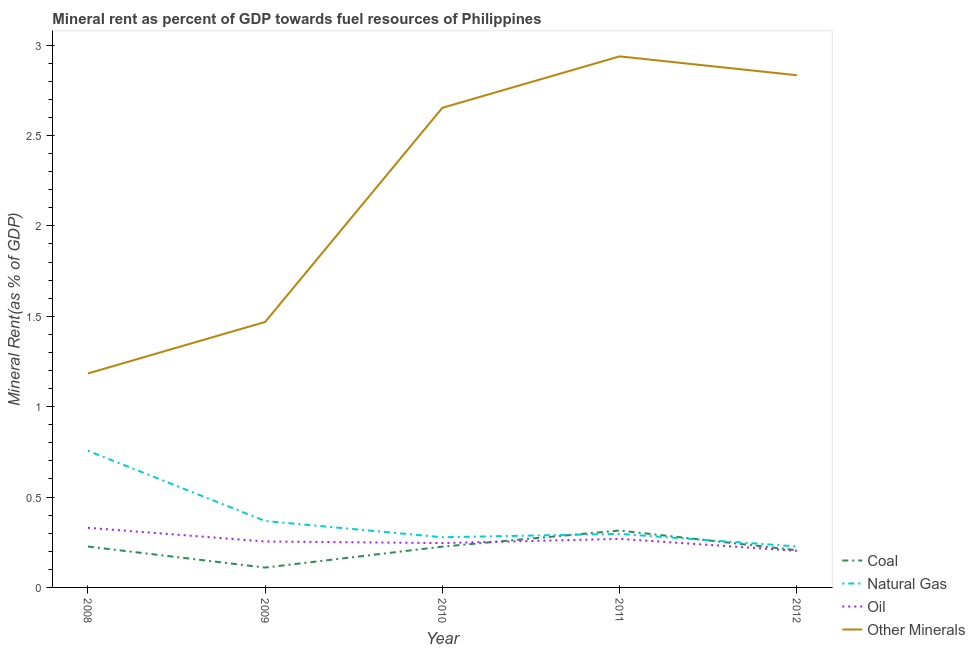What is the natural gas rent in 2011?
Your response must be concise. 0.3. Across all years, what is the maximum natural gas rent?
Your answer should be very brief. 0.76. Across all years, what is the minimum coal rent?
Your answer should be very brief. 0.11. In which year was the oil rent maximum?
Your response must be concise. 2008. In which year was the  rent of other minerals minimum?
Make the answer very short. 2008. What is the total oil rent in the graph?
Offer a very short reply. 1.3. What is the difference between the natural gas rent in 2009 and that in 2012?
Provide a succinct answer. 0.14. What is the difference between the coal rent in 2011 and the oil rent in 2009?
Your answer should be very brief. 0.06. What is the average  rent of other minerals per year?
Offer a very short reply. 2.22. In the year 2011, what is the difference between the  rent of other minerals and oil rent?
Your response must be concise. 2.67. In how many years, is the coal rent greater than 1.9 %?
Provide a succinct answer. 0. What is the ratio of the oil rent in 2010 to that in 2011?
Your answer should be very brief. 0.91. What is the difference between the highest and the second highest oil rent?
Keep it short and to the point. 0.06. What is the difference between the highest and the lowest natural gas rent?
Ensure brevity in your answer.  0.53. Is it the case that in every year, the sum of the coal rent and natural gas rent is greater than the oil rent?
Provide a short and direct response. Yes. Does the coal rent monotonically increase over the years?
Your response must be concise. No. Is the natural gas rent strictly less than the  rent of other minerals over the years?
Make the answer very short. Yes. How many legend labels are there?
Your response must be concise. 4. What is the title of the graph?
Provide a short and direct response. Mineral rent as percent of GDP towards fuel resources of Philippines. What is the label or title of the Y-axis?
Offer a very short reply. Mineral Rent(as % of GDP). What is the Mineral Rent(as % of GDP) of Coal in 2008?
Provide a short and direct response. 0.23. What is the Mineral Rent(as % of GDP) in Natural Gas in 2008?
Provide a succinct answer. 0.76. What is the Mineral Rent(as % of GDP) of Oil in 2008?
Your answer should be compact. 0.33. What is the Mineral Rent(as % of GDP) in Other Minerals in 2008?
Offer a very short reply. 1.18. What is the Mineral Rent(as % of GDP) of Coal in 2009?
Make the answer very short. 0.11. What is the Mineral Rent(as % of GDP) of Natural Gas in 2009?
Ensure brevity in your answer.  0.37. What is the Mineral Rent(as % of GDP) of Oil in 2009?
Offer a terse response. 0.25. What is the Mineral Rent(as % of GDP) of Other Minerals in 2009?
Provide a short and direct response. 1.47. What is the Mineral Rent(as % of GDP) of Coal in 2010?
Give a very brief answer. 0.23. What is the Mineral Rent(as % of GDP) in Natural Gas in 2010?
Provide a succinct answer. 0.28. What is the Mineral Rent(as % of GDP) in Oil in 2010?
Ensure brevity in your answer.  0.25. What is the Mineral Rent(as % of GDP) in Other Minerals in 2010?
Keep it short and to the point. 2.65. What is the Mineral Rent(as % of GDP) in Coal in 2011?
Offer a very short reply. 0.31. What is the Mineral Rent(as % of GDP) of Natural Gas in 2011?
Make the answer very short. 0.3. What is the Mineral Rent(as % of GDP) in Oil in 2011?
Your answer should be very brief. 0.27. What is the Mineral Rent(as % of GDP) of Other Minerals in 2011?
Give a very brief answer. 2.94. What is the Mineral Rent(as % of GDP) in Coal in 2012?
Your answer should be compact. 0.21. What is the Mineral Rent(as % of GDP) of Natural Gas in 2012?
Your answer should be compact. 0.23. What is the Mineral Rent(as % of GDP) in Oil in 2012?
Provide a succinct answer. 0.2. What is the Mineral Rent(as % of GDP) of Other Minerals in 2012?
Your response must be concise. 2.83. Across all years, what is the maximum Mineral Rent(as % of GDP) in Coal?
Give a very brief answer. 0.31. Across all years, what is the maximum Mineral Rent(as % of GDP) of Natural Gas?
Keep it short and to the point. 0.76. Across all years, what is the maximum Mineral Rent(as % of GDP) in Oil?
Provide a succinct answer. 0.33. Across all years, what is the maximum Mineral Rent(as % of GDP) in Other Minerals?
Provide a succinct answer. 2.94. Across all years, what is the minimum Mineral Rent(as % of GDP) of Coal?
Provide a succinct answer. 0.11. Across all years, what is the minimum Mineral Rent(as % of GDP) of Natural Gas?
Ensure brevity in your answer.  0.23. Across all years, what is the minimum Mineral Rent(as % of GDP) in Oil?
Give a very brief answer. 0.2. Across all years, what is the minimum Mineral Rent(as % of GDP) of Other Minerals?
Provide a succinct answer. 1.18. What is the total Mineral Rent(as % of GDP) in Coal in the graph?
Offer a terse response. 1.08. What is the total Mineral Rent(as % of GDP) of Natural Gas in the graph?
Provide a short and direct response. 1.92. What is the total Mineral Rent(as % of GDP) in Oil in the graph?
Provide a succinct answer. 1.3. What is the total Mineral Rent(as % of GDP) in Other Minerals in the graph?
Make the answer very short. 11.08. What is the difference between the Mineral Rent(as % of GDP) of Coal in 2008 and that in 2009?
Your answer should be very brief. 0.12. What is the difference between the Mineral Rent(as % of GDP) in Natural Gas in 2008 and that in 2009?
Provide a succinct answer. 0.39. What is the difference between the Mineral Rent(as % of GDP) in Oil in 2008 and that in 2009?
Give a very brief answer. 0.08. What is the difference between the Mineral Rent(as % of GDP) in Other Minerals in 2008 and that in 2009?
Your response must be concise. -0.28. What is the difference between the Mineral Rent(as % of GDP) of Coal in 2008 and that in 2010?
Keep it short and to the point. 0. What is the difference between the Mineral Rent(as % of GDP) in Natural Gas in 2008 and that in 2010?
Give a very brief answer. 0.48. What is the difference between the Mineral Rent(as % of GDP) in Oil in 2008 and that in 2010?
Keep it short and to the point. 0.08. What is the difference between the Mineral Rent(as % of GDP) in Other Minerals in 2008 and that in 2010?
Your response must be concise. -1.47. What is the difference between the Mineral Rent(as % of GDP) of Coal in 2008 and that in 2011?
Provide a succinct answer. -0.09. What is the difference between the Mineral Rent(as % of GDP) in Natural Gas in 2008 and that in 2011?
Offer a terse response. 0.46. What is the difference between the Mineral Rent(as % of GDP) of Oil in 2008 and that in 2011?
Keep it short and to the point. 0.06. What is the difference between the Mineral Rent(as % of GDP) of Other Minerals in 2008 and that in 2011?
Give a very brief answer. -1.75. What is the difference between the Mineral Rent(as % of GDP) of Coal in 2008 and that in 2012?
Offer a very short reply. 0.02. What is the difference between the Mineral Rent(as % of GDP) in Natural Gas in 2008 and that in 2012?
Offer a very short reply. 0.53. What is the difference between the Mineral Rent(as % of GDP) in Oil in 2008 and that in 2012?
Make the answer very short. 0.13. What is the difference between the Mineral Rent(as % of GDP) in Other Minerals in 2008 and that in 2012?
Your answer should be compact. -1.65. What is the difference between the Mineral Rent(as % of GDP) of Coal in 2009 and that in 2010?
Ensure brevity in your answer.  -0.12. What is the difference between the Mineral Rent(as % of GDP) of Natural Gas in 2009 and that in 2010?
Offer a very short reply. 0.09. What is the difference between the Mineral Rent(as % of GDP) of Oil in 2009 and that in 2010?
Your answer should be compact. 0.01. What is the difference between the Mineral Rent(as % of GDP) of Other Minerals in 2009 and that in 2010?
Provide a succinct answer. -1.18. What is the difference between the Mineral Rent(as % of GDP) in Coal in 2009 and that in 2011?
Keep it short and to the point. -0.2. What is the difference between the Mineral Rent(as % of GDP) in Natural Gas in 2009 and that in 2011?
Provide a short and direct response. 0.07. What is the difference between the Mineral Rent(as % of GDP) in Oil in 2009 and that in 2011?
Ensure brevity in your answer.  -0.01. What is the difference between the Mineral Rent(as % of GDP) of Other Minerals in 2009 and that in 2011?
Offer a very short reply. -1.47. What is the difference between the Mineral Rent(as % of GDP) of Coal in 2009 and that in 2012?
Your answer should be compact. -0.1. What is the difference between the Mineral Rent(as % of GDP) in Natural Gas in 2009 and that in 2012?
Ensure brevity in your answer.  0.14. What is the difference between the Mineral Rent(as % of GDP) of Oil in 2009 and that in 2012?
Offer a very short reply. 0.05. What is the difference between the Mineral Rent(as % of GDP) in Other Minerals in 2009 and that in 2012?
Your answer should be compact. -1.36. What is the difference between the Mineral Rent(as % of GDP) in Coal in 2010 and that in 2011?
Offer a terse response. -0.09. What is the difference between the Mineral Rent(as % of GDP) of Natural Gas in 2010 and that in 2011?
Ensure brevity in your answer.  -0.02. What is the difference between the Mineral Rent(as % of GDP) in Oil in 2010 and that in 2011?
Provide a short and direct response. -0.02. What is the difference between the Mineral Rent(as % of GDP) in Other Minerals in 2010 and that in 2011?
Your response must be concise. -0.28. What is the difference between the Mineral Rent(as % of GDP) in Coal in 2010 and that in 2012?
Make the answer very short. 0.02. What is the difference between the Mineral Rent(as % of GDP) in Natural Gas in 2010 and that in 2012?
Offer a very short reply. 0.05. What is the difference between the Mineral Rent(as % of GDP) in Oil in 2010 and that in 2012?
Your answer should be compact. 0.04. What is the difference between the Mineral Rent(as % of GDP) of Other Minerals in 2010 and that in 2012?
Keep it short and to the point. -0.18. What is the difference between the Mineral Rent(as % of GDP) of Coal in 2011 and that in 2012?
Give a very brief answer. 0.11. What is the difference between the Mineral Rent(as % of GDP) of Natural Gas in 2011 and that in 2012?
Offer a very short reply. 0.07. What is the difference between the Mineral Rent(as % of GDP) in Oil in 2011 and that in 2012?
Provide a succinct answer. 0.07. What is the difference between the Mineral Rent(as % of GDP) in Other Minerals in 2011 and that in 2012?
Provide a succinct answer. 0.1. What is the difference between the Mineral Rent(as % of GDP) of Coal in 2008 and the Mineral Rent(as % of GDP) of Natural Gas in 2009?
Your response must be concise. -0.14. What is the difference between the Mineral Rent(as % of GDP) of Coal in 2008 and the Mineral Rent(as % of GDP) of Oil in 2009?
Offer a terse response. -0.03. What is the difference between the Mineral Rent(as % of GDP) in Coal in 2008 and the Mineral Rent(as % of GDP) in Other Minerals in 2009?
Offer a very short reply. -1.24. What is the difference between the Mineral Rent(as % of GDP) of Natural Gas in 2008 and the Mineral Rent(as % of GDP) of Oil in 2009?
Provide a succinct answer. 0.5. What is the difference between the Mineral Rent(as % of GDP) in Natural Gas in 2008 and the Mineral Rent(as % of GDP) in Other Minerals in 2009?
Give a very brief answer. -0.71. What is the difference between the Mineral Rent(as % of GDP) in Oil in 2008 and the Mineral Rent(as % of GDP) in Other Minerals in 2009?
Your answer should be compact. -1.14. What is the difference between the Mineral Rent(as % of GDP) in Coal in 2008 and the Mineral Rent(as % of GDP) in Natural Gas in 2010?
Give a very brief answer. -0.05. What is the difference between the Mineral Rent(as % of GDP) of Coal in 2008 and the Mineral Rent(as % of GDP) of Oil in 2010?
Offer a very short reply. -0.02. What is the difference between the Mineral Rent(as % of GDP) of Coal in 2008 and the Mineral Rent(as % of GDP) of Other Minerals in 2010?
Give a very brief answer. -2.43. What is the difference between the Mineral Rent(as % of GDP) in Natural Gas in 2008 and the Mineral Rent(as % of GDP) in Oil in 2010?
Ensure brevity in your answer.  0.51. What is the difference between the Mineral Rent(as % of GDP) in Natural Gas in 2008 and the Mineral Rent(as % of GDP) in Other Minerals in 2010?
Keep it short and to the point. -1.9. What is the difference between the Mineral Rent(as % of GDP) in Oil in 2008 and the Mineral Rent(as % of GDP) in Other Minerals in 2010?
Provide a short and direct response. -2.32. What is the difference between the Mineral Rent(as % of GDP) in Coal in 2008 and the Mineral Rent(as % of GDP) in Natural Gas in 2011?
Your answer should be compact. -0.07. What is the difference between the Mineral Rent(as % of GDP) in Coal in 2008 and the Mineral Rent(as % of GDP) in Oil in 2011?
Ensure brevity in your answer.  -0.04. What is the difference between the Mineral Rent(as % of GDP) of Coal in 2008 and the Mineral Rent(as % of GDP) of Other Minerals in 2011?
Your answer should be very brief. -2.71. What is the difference between the Mineral Rent(as % of GDP) in Natural Gas in 2008 and the Mineral Rent(as % of GDP) in Oil in 2011?
Your answer should be very brief. 0.49. What is the difference between the Mineral Rent(as % of GDP) in Natural Gas in 2008 and the Mineral Rent(as % of GDP) in Other Minerals in 2011?
Your response must be concise. -2.18. What is the difference between the Mineral Rent(as % of GDP) in Oil in 2008 and the Mineral Rent(as % of GDP) in Other Minerals in 2011?
Your answer should be very brief. -2.61. What is the difference between the Mineral Rent(as % of GDP) in Coal in 2008 and the Mineral Rent(as % of GDP) in Natural Gas in 2012?
Offer a very short reply. -0. What is the difference between the Mineral Rent(as % of GDP) in Coal in 2008 and the Mineral Rent(as % of GDP) in Oil in 2012?
Give a very brief answer. 0.02. What is the difference between the Mineral Rent(as % of GDP) of Coal in 2008 and the Mineral Rent(as % of GDP) of Other Minerals in 2012?
Provide a short and direct response. -2.61. What is the difference between the Mineral Rent(as % of GDP) in Natural Gas in 2008 and the Mineral Rent(as % of GDP) in Oil in 2012?
Your answer should be compact. 0.55. What is the difference between the Mineral Rent(as % of GDP) in Natural Gas in 2008 and the Mineral Rent(as % of GDP) in Other Minerals in 2012?
Offer a terse response. -2.08. What is the difference between the Mineral Rent(as % of GDP) in Oil in 2008 and the Mineral Rent(as % of GDP) in Other Minerals in 2012?
Ensure brevity in your answer.  -2.5. What is the difference between the Mineral Rent(as % of GDP) in Coal in 2009 and the Mineral Rent(as % of GDP) in Natural Gas in 2010?
Offer a very short reply. -0.17. What is the difference between the Mineral Rent(as % of GDP) in Coal in 2009 and the Mineral Rent(as % of GDP) in Oil in 2010?
Offer a terse response. -0.14. What is the difference between the Mineral Rent(as % of GDP) in Coal in 2009 and the Mineral Rent(as % of GDP) in Other Minerals in 2010?
Your answer should be compact. -2.54. What is the difference between the Mineral Rent(as % of GDP) in Natural Gas in 2009 and the Mineral Rent(as % of GDP) in Oil in 2010?
Offer a terse response. 0.12. What is the difference between the Mineral Rent(as % of GDP) in Natural Gas in 2009 and the Mineral Rent(as % of GDP) in Other Minerals in 2010?
Give a very brief answer. -2.29. What is the difference between the Mineral Rent(as % of GDP) of Oil in 2009 and the Mineral Rent(as % of GDP) of Other Minerals in 2010?
Give a very brief answer. -2.4. What is the difference between the Mineral Rent(as % of GDP) in Coal in 2009 and the Mineral Rent(as % of GDP) in Natural Gas in 2011?
Your response must be concise. -0.19. What is the difference between the Mineral Rent(as % of GDP) in Coal in 2009 and the Mineral Rent(as % of GDP) in Oil in 2011?
Give a very brief answer. -0.16. What is the difference between the Mineral Rent(as % of GDP) in Coal in 2009 and the Mineral Rent(as % of GDP) in Other Minerals in 2011?
Make the answer very short. -2.83. What is the difference between the Mineral Rent(as % of GDP) of Natural Gas in 2009 and the Mineral Rent(as % of GDP) of Oil in 2011?
Give a very brief answer. 0.1. What is the difference between the Mineral Rent(as % of GDP) of Natural Gas in 2009 and the Mineral Rent(as % of GDP) of Other Minerals in 2011?
Ensure brevity in your answer.  -2.57. What is the difference between the Mineral Rent(as % of GDP) in Oil in 2009 and the Mineral Rent(as % of GDP) in Other Minerals in 2011?
Offer a very short reply. -2.68. What is the difference between the Mineral Rent(as % of GDP) in Coal in 2009 and the Mineral Rent(as % of GDP) in Natural Gas in 2012?
Ensure brevity in your answer.  -0.12. What is the difference between the Mineral Rent(as % of GDP) in Coal in 2009 and the Mineral Rent(as % of GDP) in Oil in 2012?
Give a very brief answer. -0.09. What is the difference between the Mineral Rent(as % of GDP) of Coal in 2009 and the Mineral Rent(as % of GDP) of Other Minerals in 2012?
Your answer should be compact. -2.72. What is the difference between the Mineral Rent(as % of GDP) of Natural Gas in 2009 and the Mineral Rent(as % of GDP) of Oil in 2012?
Keep it short and to the point. 0.17. What is the difference between the Mineral Rent(as % of GDP) of Natural Gas in 2009 and the Mineral Rent(as % of GDP) of Other Minerals in 2012?
Provide a succinct answer. -2.47. What is the difference between the Mineral Rent(as % of GDP) of Oil in 2009 and the Mineral Rent(as % of GDP) of Other Minerals in 2012?
Make the answer very short. -2.58. What is the difference between the Mineral Rent(as % of GDP) in Coal in 2010 and the Mineral Rent(as % of GDP) in Natural Gas in 2011?
Provide a succinct answer. -0.07. What is the difference between the Mineral Rent(as % of GDP) in Coal in 2010 and the Mineral Rent(as % of GDP) in Oil in 2011?
Keep it short and to the point. -0.04. What is the difference between the Mineral Rent(as % of GDP) in Coal in 2010 and the Mineral Rent(as % of GDP) in Other Minerals in 2011?
Provide a succinct answer. -2.71. What is the difference between the Mineral Rent(as % of GDP) in Natural Gas in 2010 and the Mineral Rent(as % of GDP) in Oil in 2011?
Your response must be concise. 0.01. What is the difference between the Mineral Rent(as % of GDP) in Natural Gas in 2010 and the Mineral Rent(as % of GDP) in Other Minerals in 2011?
Your answer should be very brief. -2.66. What is the difference between the Mineral Rent(as % of GDP) in Oil in 2010 and the Mineral Rent(as % of GDP) in Other Minerals in 2011?
Ensure brevity in your answer.  -2.69. What is the difference between the Mineral Rent(as % of GDP) in Coal in 2010 and the Mineral Rent(as % of GDP) in Natural Gas in 2012?
Your answer should be very brief. -0. What is the difference between the Mineral Rent(as % of GDP) in Coal in 2010 and the Mineral Rent(as % of GDP) in Oil in 2012?
Your answer should be compact. 0.02. What is the difference between the Mineral Rent(as % of GDP) of Coal in 2010 and the Mineral Rent(as % of GDP) of Other Minerals in 2012?
Provide a short and direct response. -2.61. What is the difference between the Mineral Rent(as % of GDP) in Natural Gas in 2010 and the Mineral Rent(as % of GDP) in Oil in 2012?
Make the answer very short. 0.07. What is the difference between the Mineral Rent(as % of GDP) in Natural Gas in 2010 and the Mineral Rent(as % of GDP) in Other Minerals in 2012?
Make the answer very short. -2.56. What is the difference between the Mineral Rent(as % of GDP) of Oil in 2010 and the Mineral Rent(as % of GDP) of Other Minerals in 2012?
Offer a terse response. -2.59. What is the difference between the Mineral Rent(as % of GDP) of Coal in 2011 and the Mineral Rent(as % of GDP) of Natural Gas in 2012?
Your response must be concise. 0.09. What is the difference between the Mineral Rent(as % of GDP) in Coal in 2011 and the Mineral Rent(as % of GDP) in Oil in 2012?
Provide a short and direct response. 0.11. What is the difference between the Mineral Rent(as % of GDP) of Coal in 2011 and the Mineral Rent(as % of GDP) of Other Minerals in 2012?
Your answer should be very brief. -2.52. What is the difference between the Mineral Rent(as % of GDP) of Natural Gas in 2011 and the Mineral Rent(as % of GDP) of Oil in 2012?
Provide a succinct answer. 0.09. What is the difference between the Mineral Rent(as % of GDP) in Natural Gas in 2011 and the Mineral Rent(as % of GDP) in Other Minerals in 2012?
Give a very brief answer. -2.54. What is the difference between the Mineral Rent(as % of GDP) of Oil in 2011 and the Mineral Rent(as % of GDP) of Other Minerals in 2012?
Provide a short and direct response. -2.56. What is the average Mineral Rent(as % of GDP) in Coal per year?
Provide a succinct answer. 0.22. What is the average Mineral Rent(as % of GDP) of Natural Gas per year?
Keep it short and to the point. 0.38. What is the average Mineral Rent(as % of GDP) in Oil per year?
Provide a short and direct response. 0.26. What is the average Mineral Rent(as % of GDP) in Other Minerals per year?
Keep it short and to the point. 2.22. In the year 2008, what is the difference between the Mineral Rent(as % of GDP) of Coal and Mineral Rent(as % of GDP) of Natural Gas?
Ensure brevity in your answer.  -0.53. In the year 2008, what is the difference between the Mineral Rent(as % of GDP) of Coal and Mineral Rent(as % of GDP) of Oil?
Offer a terse response. -0.1. In the year 2008, what is the difference between the Mineral Rent(as % of GDP) of Coal and Mineral Rent(as % of GDP) of Other Minerals?
Your response must be concise. -0.96. In the year 2008, what is the difference between the Mineral Rent(as % of GDP) in Natural Gas and Mineral Rent(as % of GDP) in Oil?
Give a very brief answer. 0.43. In the year 2008, what is the difference between the Mineral Rent(as % of GDP) of Natural Gas and Mineral Rent(as % of GDP) of Other Minerals?
Ensure brevity in your answer.  -0.43. In the year 2008, what is the difference between the Mineral Rent(as % of GDP) of Oil and Mineral Rent(as % of GDP) of Other Minerals?
Your answer should be compact. -0.85. In the year 2009, what is the difference between the Mineral Rent(as % of GDP) in Coal and Mineral Rent(as % of GDP) in Natural Gas?
Your answer should be very brief. -0.26. In the year 2009, what is the difference between the Mineral Rent(as % of GDP) of Coal and Mineral Rent(as % of GDP) of Oil?
Your answer should be very brief. -0.14. In the year 2009, what is the difference between the Mineral Rent(as % of GDP) in Coal and Mineral Rent(as % of GDP) in Other Minerals?
Your answer should be compact. -1.36. In the year 2009, what is the difference between the Mineral Rent(as % of GDP) of Natural Gas and Mineral Rent(as % of GDP) of Oil?
Your answer should be very brief. 0.11. In the year 2009, what is the difference between the Mineral Rent(as % of GDP) of Natural Gas and Mineral Rent(as % of GDP) of Other Minerals?
Your answer should be very brief. -1.1. In the year 2009, what is the difference between the Mineral Rent(as % of GDP) in Oil and Mineral Rent(as % of GDP) in Other Minerals?
Offer a terse response. -1.21. In the year 2010, what is the difference between the Mineral Rent(as % of GDP) in Coal and Mineral Rent(as % of GDP) in Natural Gas?
Your response must be concise. -0.05. In the year 2010, what is the difference between the Mineral Rent(as % of GDP) in Coal and Mineral Rent(as % of GDP) in Oil?
Offer a very short reply. -0.02. In the year 2010, what is the difference between the Mineral Rent(as % of GDP) of Coal and Mineral Rent(as % of GDP) of Other Minerals?
Your answer should be compact. -2.43. In the year 2010, what is the difference between the Mineral Rent(as % of GDP) in Natural Gas and Mineral Rent(as % of GDP) in Oil?
Offer a very short reply. 0.03. In the year 2010, what is the difference between the Mineral Rent(as % of GDP) in Natural Gas and Mineral Rent(as % of GDP) in Other Minerals?
Provide a short and direct response. -2.38. In the year 2010, what is the difference between the Mineral Rent(as % of GDP) in Oil and Mineral Rent(as % of GDP) in Other Minerals?
Keep it short and to the point. -2.41. In the year 2011, what is the difference between the Mineral Rent(as % of GDP) of Coal and Mineral Rent(as % of GDP) of Natural Gas?
Provide a succinct answer. 0.02. In the year 2011, what is the difference between the Mineral Rent(as % of GDP) in Coal and Mineral Rent(as % of GDP) in Oil?
Make the answer very short. 0.05. In the year 2011, what is the difference between the Mineral Rent(as % of GDP) of Coal and Mineral Rent(as % of GDP) of Other Minerals?
Your answer should be very brief. -2.62. In the year 2011, what is the difference between the Mineral Rent(as % of GDP) of Natural Gas and Mineral Rent(as % of GDP) of Oil?
Your answer should be very brief. 0.03. In the year 2011, what is the difference between the Mineral Rent(as % of GDP) in Natural Gas and Mineral Rent(as % of GDP) in Other Minerals?
Provide a short and direct response. -2.64. In the year 2011, what is the difference between the Mineral Rent(as % of GDP) of Oil and Mineral Rent(as % of GDP) of Other Minerals?
Your answer should be very brief. -2.67. In the year 2012, what is the difference between the Mineral Rent(as % of GDP) in Coal and Mineral Rent(as % of GDP) in Natural Gas?
Your response must be concise. -0.02. In the year 2012, what is the difference between the Mineral Rent(as % of GDP) of Coal and Mineral Rent(as % of GDP) of Oil?
Your response must be concise. 0. In the year 2012, what is the difference between the Mineral Rent(as % of GDP) in Coal and Mineral Rent(as % of GDP) in Other Minerals?
Offer a very short reply. -2.63. In the year 2012, what is the difference between the Mineral Rent(as % of GDP) in Natural Gas and Mineral Rent(as % of GDP) in Oil?
Ensure brevity in your answer.  0.02. In the year 2012, what is the difference between the Mineral Rent(as % of GDP) of Natural Gas and Mineral Rent(as % of GDP) of Other Minerals?
Give a very brief answer. -2.61. In the year 2012, what is the difference between the Mineral Rent(as % of GDP) in Oil and Mineral Rent(as % of GDP) in Other Minerals?
Provide a short and direct response. -2.63. What is the ratio of the Mineral Rent(as % of GDP) in Coal in 2008 to that in 2009?
Your answer should be very brief. 2.06. What is the ratio of the Mineral Rent(as % of GDP) in Natural Gas in 2008 to that in 2009?
Your response must be concise. 2.06. What is the ratio of the Mineral Rent(as % of GDP) of Oil in 2008 to that in 2009?
Ensure brevity in your answer.  1.3. What is the ratio of the Mineral Rent(as % of GDP) of Other Minerals in 2008 to that in 2009?
Keep it short and to the point. 0.81. What is the ratio of the Mineral Rent(as % of GDP) of Natural Gas in 2008 to that in 2010?
Provide a short and direct response. 2.72. What is the ratio of the Mineral Rent(as % of GDP) in Oil in 2008 to that in 2010?
Give a very brief answer. 1.34. What is the ratio of the Mineral Rent(as % of GDP) in Other Minerals in 2008 to that in 2010?
Provide a short and direct response. 0.45. What is the ratio of the Mineral Rent(as % of GDP) of Coal in 2008 to that in 2011?
Offer a very short reply. 0.72. What is the ratio of the Mineral Rent(as % of GDP) in Natural Gas in 2008 to that in 2011?
Keep it short and to the point. 2.55. What is the ratio of the Mineral Rent(as % of GDP) of Oil in 2008 to that in 2011?
Your answer should be compact. 1.23. What is the ratio of the Mineral Rent(as % of GDP) of Other Minerals in 2008 to that in 2011?
Give a very brief answer. 0.4. What is the ratio of the Mineral Rent(as % of GDP) of Coal in 2008 to that in 2012?
Offer a terse response. 1.1. What is the ratio of the Mineral Rent(as % of GDP) in Natural Gas in 2008 to that in 2012?
Keep it short and to the point. 3.33. What is the ratio of the Mineral Rent(as % of GDP) in Oil in 2008 to that in 2012?
Offer a terse response. 1.63. What is the ratio of the Mineral Rent(as % of GDP) in Other Minerals in 2008 to that in 2012?
Give a very brief answer. 0.42. What is the ratio of the Mineral Rent(as % of GDP) in Coal in 2009 to that in 2010?
Keep it short and to the point. 0.49. What is the ratio of the Mineral Rent(as % of GDP) in Natural Gas in 2009 to that in 2010?
Your response must be concise. 1.32. What is the ratio of the Mineral Rent(as % of GDP) in Oil in 2009 to that in 2010?
Provide a short and direct response. 1.04. What is the ratio of the Mineral Rent(as % of GDP) of Other Minerals in 2009 to that in 2010?
Make the answer very short. 0.55. What is the ratio of the Mineral Rent(as % of GDP) in Coal in 2009 to that in 2011?
Provide a succinct answer. 0.35. What is the ratio of the Mineral Rent(as % of GDP) of Natural Gas in 2009 to that in 2011?
Your answer should be compact. 1.24. What is the ratio of the Mineral Rent(as % of GDP) of Oil in 2009 to that in 2011?
Provide a succinct answer. 0.95. What is the ratio of the Mineral Rent(as % of GDP) of Other Minerals in 2009 to that in 2011?
Ensure brevity in your answer.  0.5. What is the ratio of the Mineral Rent(as % of GDP) in Coal in 2009 to that in 2012?
Make the answer very short. 0.53. What is the ratio of the Mineral Rent(as % of GDP) in Natural Gas in 2009 to that in 2012?
Give a very brief answer. 1.62. What is the ratio of the Mineral Rent(as % of GDP) of Oil in 2009 to that in 2012?
Your answer should be compact. 1.26. What is the ratio of the Mineral Rent(as % of GDP) of Other Minerals in 2009 to that in 2012?
Keep it short and to the point. 0.52. What is the ratio of the Mineral Rent(as % of GDP) in Coal in 2010 to that in 2011?
Your answer should be compact. 0.72. What is the ratio of the Mineral Rent(as % of GDP) of Natural Gas in 2010 to that in 2011?
Offer a very short reply. 0.94. What is the ratio of the Mineral Rent(as % of GDP) of Oil in 2010 to that in 2011?
Give a very brief answer. 0.91. What is the ratio of the Mineral Rent(as % of GDP) in Other Minerals in 2010 to that in 2011?
Make the answer very short. 0.9. What is the ratio of the Mineral Rent(as % of GDP) in Coal in 2010 to that in 2012?
Offer a very short reply. 1.1. What is the ratio of the Mineral Rent(as % of GDP) in Natural Gas in 2010 to that in 2012?
Your response must be concise. 1.22. What is the ratio of the Mineral Rent(as % of GDP) in Oil in 2010 to that in 2012?
Ensure brevity in your answer.  1.21. What is the ratio of the Mineral Rent(as % of GDP) of Other Minerals in 2010 to that in 2012?
Provide a succinct answer. 0.94. What is the ratio of the Mineral Rent(as % of GDP) of Coal in 2011 to that in 2012?
Provide a short and direct response. 1.53. What is the ratio of the Mineral Rent(as % of GDP) in Natural Gas in 2011 to that in 2012?
Ensure brevity in your answer.  1.31. What is the ratio of the Mineral Rent(as % of GDP) of Oil in 2011 to that in 2012?
Provide a succinct answer. 1.33. What is the ratio of the Mineral Rent(as % of GDP) of Other Minerals in 2011 to that in 2012?
Your answer should be compact. 1.04. What is the difference between the highest and the second highest Mineral Rent(as % of GDP) of Coal?
Make the answer very short. 0.09. What is the difference between the highest and the second highest Mineral Rent(as % of GDP) of Natural Gas?
Your answer should be compact. 0.39. What is the difference between the highest and the second highest Mineral Rent(as % of GDP) in Oil?
Keep it short and to the point. 0.06. What is the difference between the highest and the second highest Mineral Rent(as % of GDP) in Other Minerals?
Keep it short and to the point. 0.1. What is the difference between the highest and the lowest Mineral Rent(as % of GDP) of Coal?
Make the answer very short. 0.2. What is the difference between the highest and the lowest Mineral Rent(as % of GDP) in Natural Gas?
Your answer should be compact. 0.53. What is the difference between the highest and the lowest Mineral Rent(as % of GDP) in Oil?
Make the answer very short. 0.13. What is the difference between the highest and the lowest Mineral Rent(as % of GDP) in Other Minerals?
Your answer should be very brief. 1.75. 